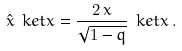Convert formula to latex. <formula><loc_0><loc_0><loc_500><loc_500>\hat { x } \ k e t { x } = \frac { 2 \, x } { \sqrt { 1 - q } } \ k e t { x } \, .</formula> 